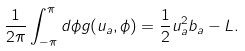<formula> <loc_0><loc_0><loc_500><loc_500>\frac { 1 } { 2 \pi } \int _ { - \pi } ^ { \pi } d \phi g ( u _ { a } , \phi ) = \frac { 1 } { 2 } u _ { a } ^ { 2 } b _ { a } - L .</formula> 